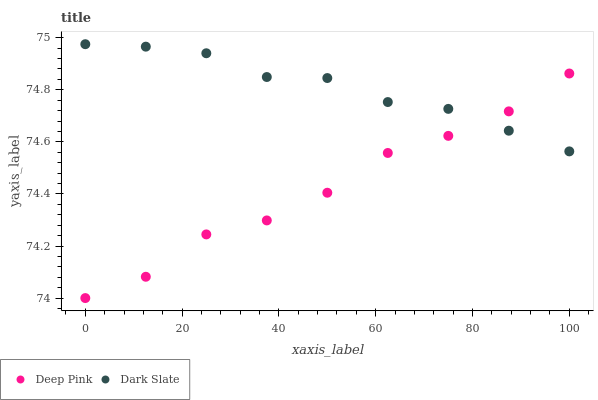Does Deep Pink have the minimum area under the curve?
Answer yes or no. Yes. Does Dark Slate have the maximum area under the curve?
Answer yes or no. Yes. Does Deep Pink have the maximum area under the curve?
Answer yes or no. No. Is Dark Slate the smoothest?
Answer yes or no. Yes. Is Deep Pink the roughest?
Answer yes or no. Yes. Is Deep Pink the smoothest?
Answer yes or no. No. Does Deep Pink have the lowest value?
Answer yes or no. Yes. Does Dark Slate have the highest value?
Answer yes or no. Yes. Does Deep Pink have the highest value?
Answer yes or no. No. Does Dark Slate intersect Deep Pink?
Answer yes or no. Yes. Is Dark Slate less than Deep Pink?
Answer yes or no. No. Is Dark Slate greater than Deep Pink?
Answer yes or no. No. 